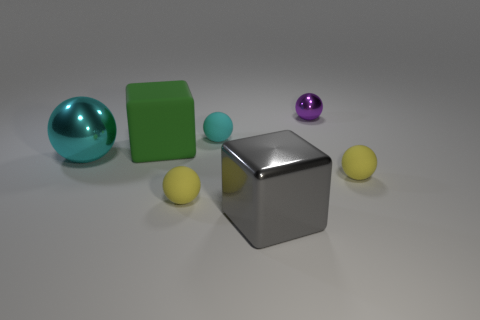There is a tiny rubber thing that is the same color as the big sphere; what shape is it?
Provide a short and direct response. Sphere. There is a yellow object behind the tiny yellow rubber sphere on the left side of the tiny metallic thing; is there a tiny rubber sphere in front of it?
Your answer should be compact. Yes. Do the purple metallic object and the cyan rubber sphere have the same size?
Ensure brevity in your answer.  Yes. Are there the same number of large cyan metallic spheres behind the tiny purple metallic thing and large objects behind the big cyan object?
Make the answer very short. No. What shape is the yellow rubber object on the left side of the tiny purple metal sphere?
Your answer should be compact. Sphere. There is a gray thing that is the same size as the green object; what is its shape?
Your answer should be compact. Cube. What is the color of the small metallic object that is to the right of the cyan ball that is behind the cyan metal thing that is on the left side of the cyan rubber thing?
Provide a short and direct response. Purple. Do the gray object and the green object have the same shape?
Your answer should be compact. Yes. Are there an equal number of small metallic things in front of the big cyan metallic ball and large cyan rubber things?
Keep it short and to the point. Yes. What number of other objects are the same material as the gray object?
Your answer should be very brief. 2. 